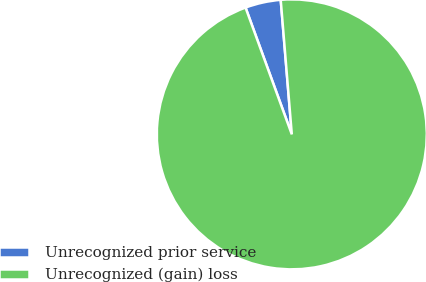Convert chart. <chart><loc_0><loc_0><loc_500><loc_500><pie_chart><fcel>Unrecognized prior service<fcel>Unrecognized (gain) loss<nl><fcel>4.26%<fcel>95.74%<nl></chart> 